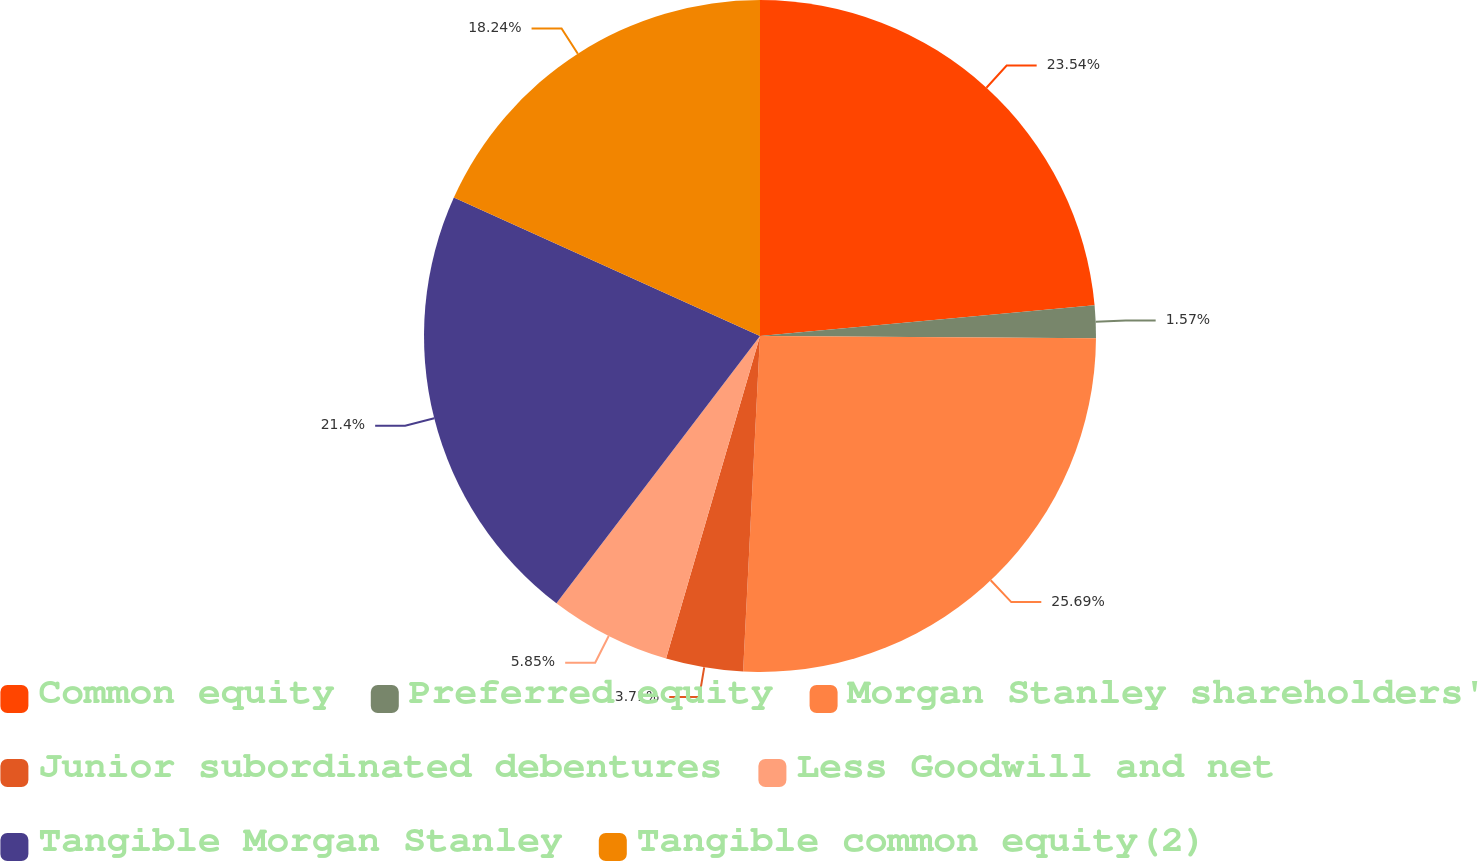<chart> <loc_0><loc_0><loc_500><loc_500><pie_chart><fcel>Common equity<fcel>Preferred equity<fcel>Morgan Stanley shareholders'<fcel>Junior subordinated debentures<fcel>Less Goodwill and net<fcel>Tangible Morgan Stanley<fcel>Tangible common equity(2)<nl><fcel>23.54%<fcel>1.57%<fcel>25.69%<fcel>3.71%<fcel>5.85%<fcel>21.4%<fcel>18.24%<nl></chart> 